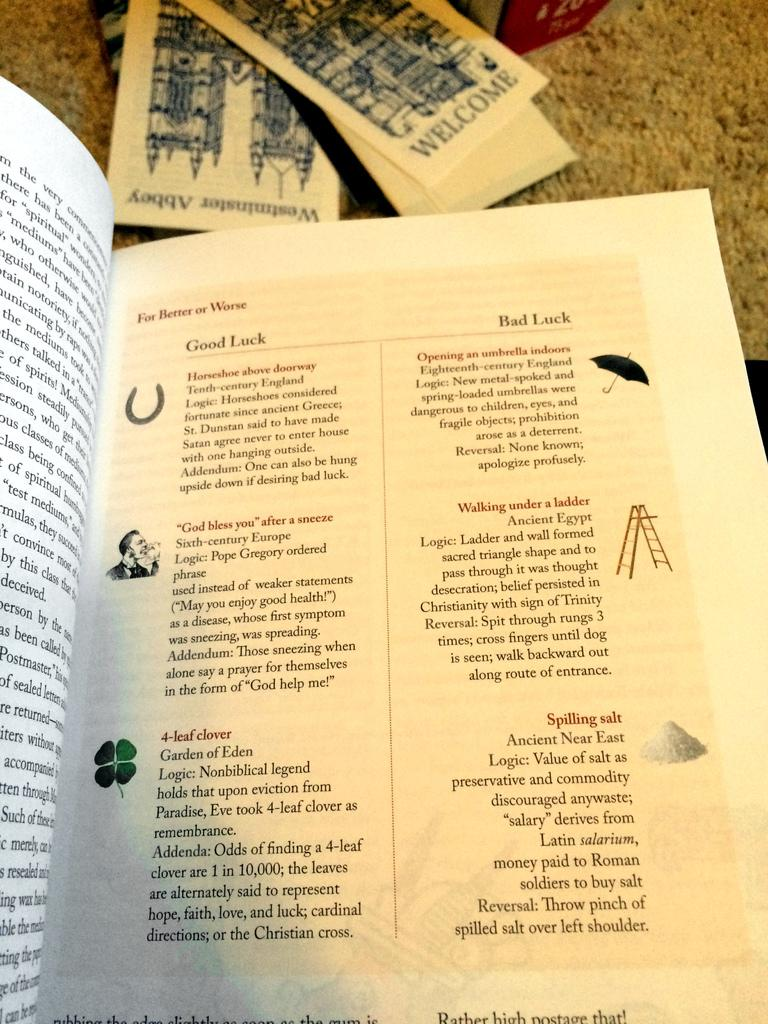<image>
Create a compact narrative representing the image presented. A book is open to a page that says Good luck and Bad luck. 